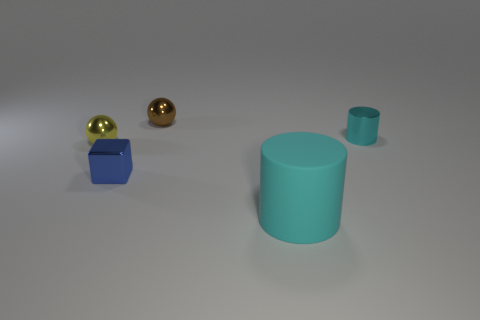Are there more big objects than brown metal cylinders?
Your response must be concise. Yes. What is the color of the ball that is behind the cyan metallic cylinder?
Your answer should be very brief. Brown. Is the shape of the tiny brown object the same as the large rubber thing?
Give a very brief answer. No. What is the color of the small metallic object that is both in front of the brown metal ball and behind the small yellow metallic object?
Provide a succinct answer. Cyan. There is a ball on the left side of the shiny block; is its size the same as the metallic object to the right of the cyan matte thing?
Keep it short and to the point. Yes. What number of things are small shiny spheres that are to the right of the yellow object or large brown blocks?
Your answer should be very brief. 1. What is the large cyan cylinder made of?
Your response must be concise. Rubber. Do the cyan metal cylinder and the metallic cube have the same size?
Give a very brief answer. Yes. How many cylinders are either big brown things or tiny shiny objects?
Offer a very short reply. 1. The metallic object right of the object behind the small cyan cylinder is what color?
Offer a terse response. Cyan. 